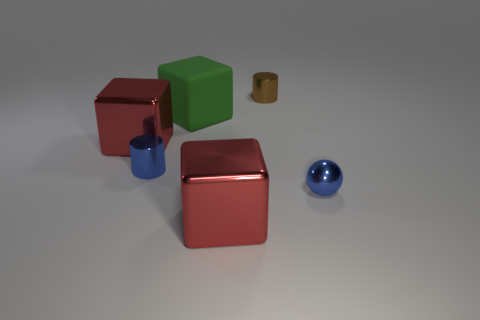Is there anything else that has the same material as the green thing?
Your answer should be very brief. No. There is a metallic sphere; does it have the same size as the red object that is to the left of the green rubber thing?
Provide a succinct answer. No. How many metal things are big green objects or cylinders?
Provide a short and direct response. 2. How many red metal things have the same shape as the brown object?
Offer a terse response. 0. There is a tiny cylinder that is the same color as the small shiny sphere; what is it made of?
Your response must be concise. Metal. Does the blue object to the right of the brown metallic cylinder have the same size as the blue metal thing that is on the left side of the big green rubber thing?
Your answer should be compact. Yes. What shape is the small metal object behind the big rubber block?
Your response must be concise. Cylinder. What material is the blue thing that is the same shape as the small brown metal thing?
Provide a short and direct response. Metal. Is the size of the blue object that is right of the brown cylinder the same as the large matte thing?
Make the answer very short. No. How many large green matte cubes are behind the small blue sphere?
Give a very brief answer. 1. 